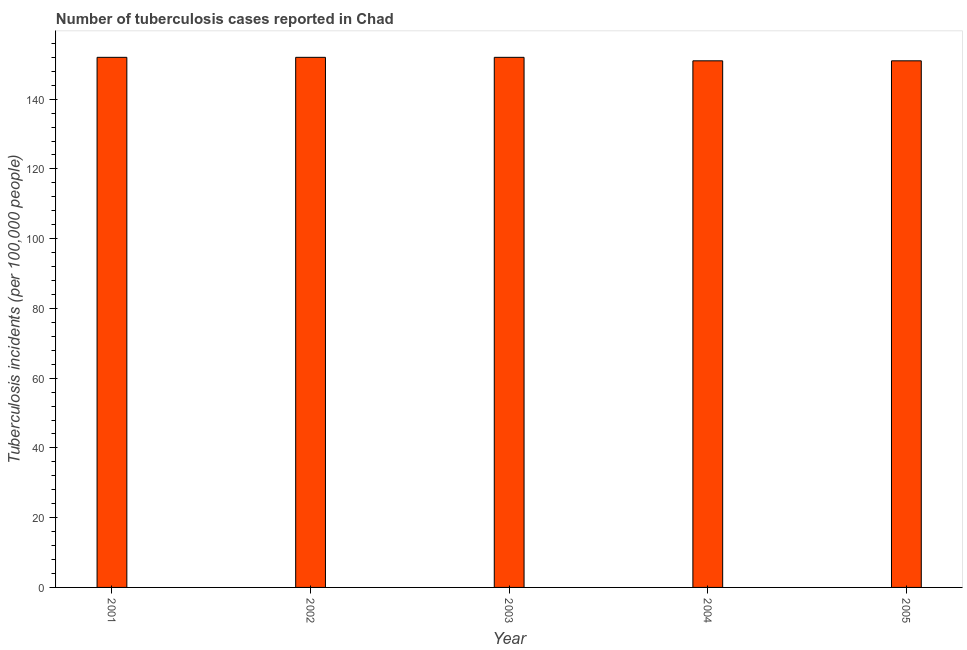What is the title of the graph?
Give a very brief answer. Number of tuberculosis cases reported in Chad. What is the label or title of the X-axis?
Your response must be concise. Year. What is the label or title of the Y-axis?
Your answer should be very brief. Tuberculosis incidents (per 100,0 people). What is the number of tuberculosis incidents in 2001?
Your answer should be very brief. 152. Across all years, what is the maximum number of tuberculosis incidents?
Ensure brevity in your answer.  152. Across all years, what is the minimum number of tuberculosis incidents?
Provide a short and direct response. 151. What is the sum of the number of tuberculosis incidents?
Ensure brevity in your answer.  758. What is the difference between the number of tuberculosis incidents in 2001 and 2005?
Make the answer very short. 1. What is the average number of tuberculosis incidents per year?
Provide a succinct answer. 151. What is the median number of tuberculosis incidents?
Make the answer very short. 152. Do a majority of the years between 2002 and 2003 (inclusive) have number of tuberculosis incidents greater than 44 ?
Make the answer very short. Yes. Is the sum of the number of tuberculosis incidents in 2002 and 2005 greater than the maximum number of tuberculosis incidents across all years?
Make the answer very short. Yes. In how many years, is the number of tuberculosis incidents greater than the average number of tuberculosis incidents taken over all years?
Your response must be concise. 3. Are all the bars in the graph horizontal?
Keep it short and to the point. No. What is the difference between two consecutive major ticks on the Y-axis?
Provide a succinct answer. 20. Are the values on the major ticks of Y-axis written in scientific E-notation?
Ensure brevity in your answer.  No. What is the Tuberculosis incidents (per 100,000 people) of 2001?
Your answer should be compact. 152. What is the Tuberculosis incidents (per 100,000 people) in 2002?
Ensure brevity in your answer.  152. What is the Tuberculosis incidents (per 100,000 people) in 2003?
Make the answer very short. 152. What is the Tuberculosis incidents (per 100,000 people) in 2004?
Provide a succinct answer. 151. What is the Tuberculosis incidents (per 100,000 people) of 2005?
Offer a terse response. 151. What is the difference between the Tuberculosis incidents (per 100,000 people) in 2001 and 2004?
Give a very brief answer. 1. What is the difference between the Tuberculosis incidents (per 100,000 people) in 2002 and 2004?
Your response must be concise. 1. What is the difference between the Tuberculosis incidents (per 100,000 people) in 2002 and 2005?
Ensure brevity in your answer.  1. What is the difference between the Tuberculosis incidents (per 100,000 people) in 2003 and 2005?
Your answer should be very brief. 1. What is the difference between the Tuberculosis incidents (per 100,000 people) in 2004 and 2005?
Your answer should be compact. 0. What is the ratio of the Tuberculosis incidents (per 100,000 people) in 2001 to that in 2003?
Your answer should be compact. 1. What is the ratio of the Tuberculosis incidents (per 100,000 people) in 2001 to that in 2005?
Offer a terse response. 1.01. What is the ratio of the Tuberculosis incidents (per 100,000 people) in 2002 to that in 2003?
Provide a succinct answer. 1. What is the ratio of the Tuberculosis incidents (per 100,000 people) in 2002 to that in 2004?
Give a very brief answer. 1.01. What is the ratio of the Tuberculosis incidents (per 100,000 people) in 2002 to that in 2005?
Give a very brief answer. 1.01. What is the ratio of the Tuberculosis incidents (per 100,000 people) in 2003 to that in 2004?
Provide a short and direct response. 1.01. 